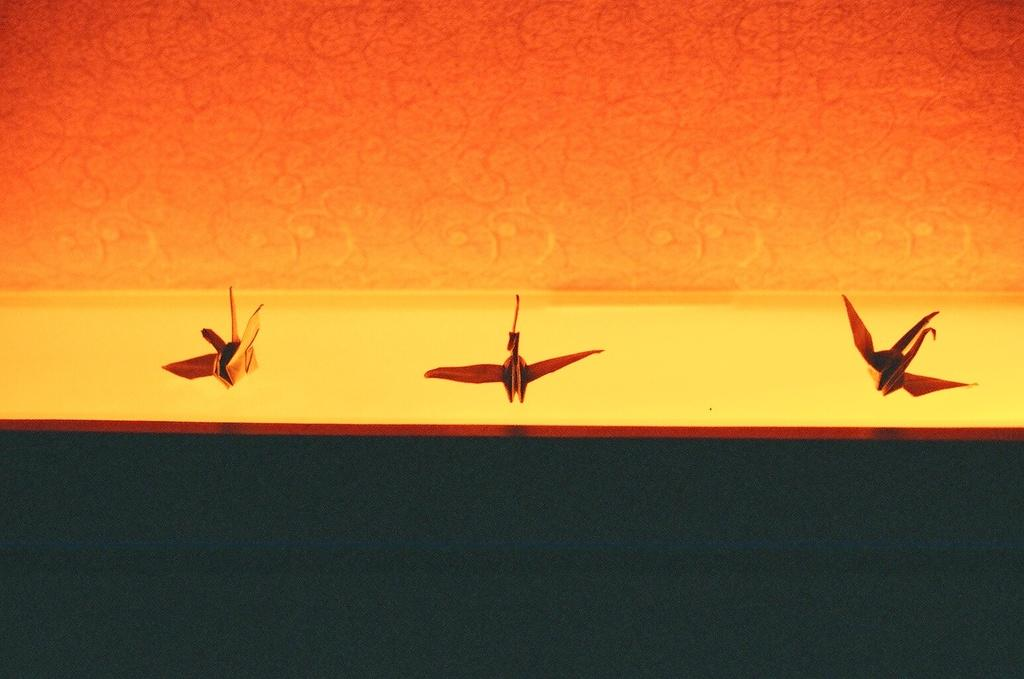What is the surface on which the objects are placed in the image? There is a wooden platform in the image on which the objects are placed. What can be seen in the background of the image? There is a wall in the background of the image. What type of table is being offered to the objects in the image? There is no table being offered to the objects in the image, as the objects are already placed on a wooden platform. How many fingers are visible in the image? There is no mention of fingers or hands in the image, so it is not possible to determine how many fingers are visible. 